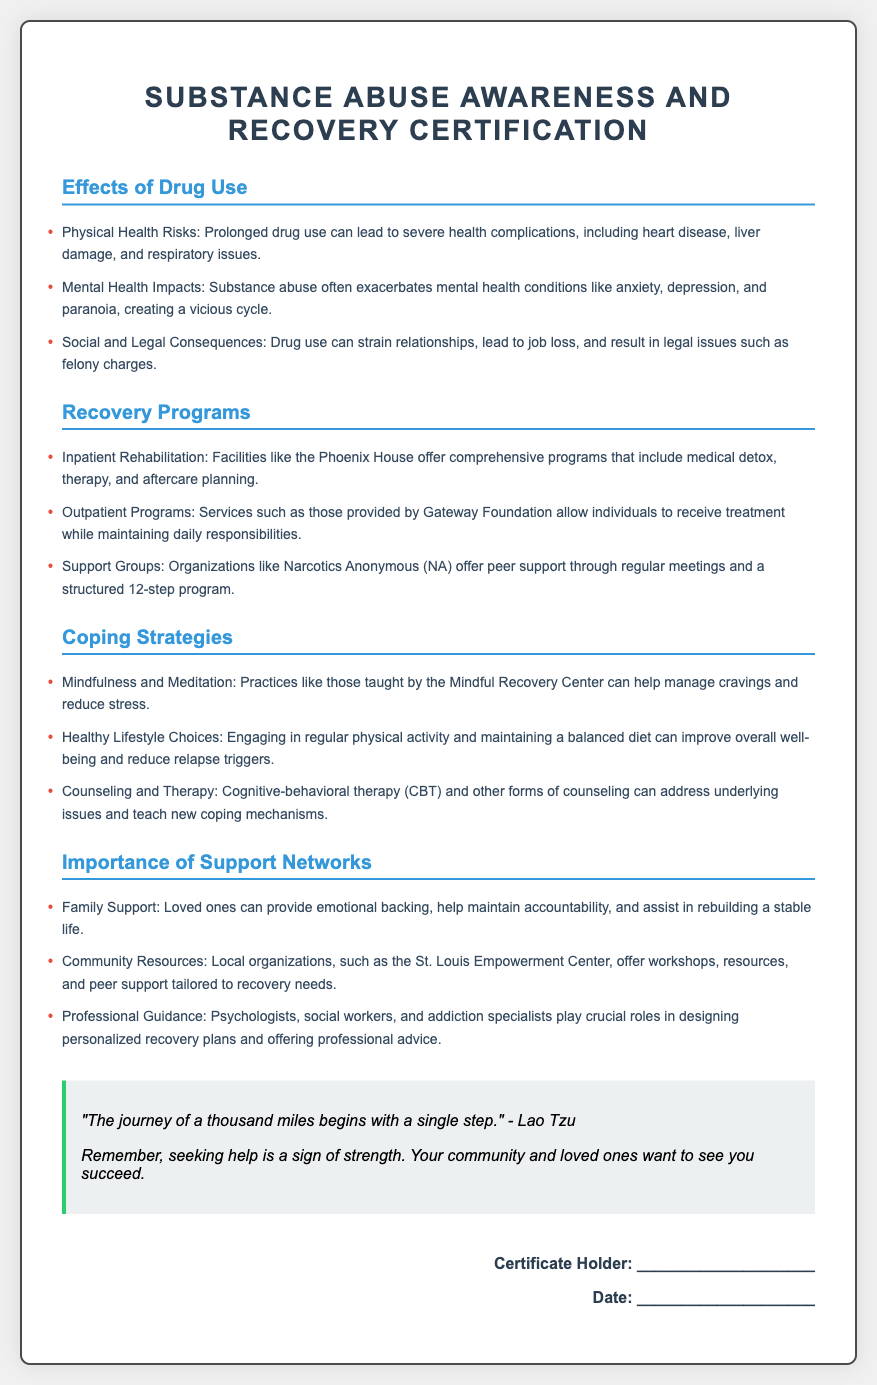What are the physical health risks of drug use? The document lists physical health risks including severe health complications like heart disease, liver damage, and respiratory issues.
Answer: Heart disease, liver damage, respiratory issues What type of program does the Phoenix House offer? The Phoenix House is mentioned as providing inpatient rehabilitation that includes medical detox, therapy, and aftercare planning.
Answer: Inpatient Rehabilitation Which support group is associated with a 12-step program? Narcotics Anonymous (NA) is identified in the document as offering peer support through a structured 12-step program.
Answer: Narcotics Anonymous What coping strategy involves managing cravings through mindfulness? Mindfulness and meditation are highlighted as practices that help manage cravings and reduce stress.
Answer: Mindfulness and Meditation What is a beneficial lifestyle choice mentioned in coping strategies? Engaging in regular physical activity and maintaining a balanced diet are noted as healthy lifestyle choices.
Answer: Regular physical activity, balanced diet How does family support assist in recovery? The document states that family support provides emotional backing, accountability, and helps in rebuilding a stable life.
Answer: Emotional backing, accountability, stable life What community resource is mentioned for workshops and peer support? The St. Louis Empowerment Center is referenced as a local organization offering workshops, resources, and peer support.
Answer: St. Louis Empowerment Center What quote is included for motivation? The document includes the motivational quote by Lao Tzu: "The journey of a thousand miles begins with a single step."
Answer: "The journey of a thousand miles begins with a single step." What is the document's title? The title of the document is prominently displayed at the top as "Substance Abuse Awareness and Recovery Certification."
Answer: Substance Abuse Awareness and Recovery Certification Who can provide professional guidance in recovery? The document lists psychologists, social workers, and addiction specialists as those who play crucial roles in designing recovery plans.
Answer: Psychologists, social workers, addiction specialists 